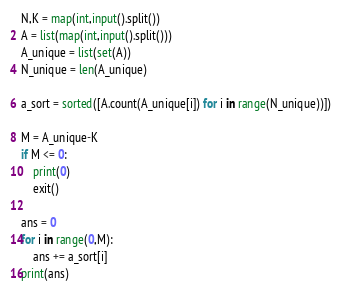<code> <loc_0><loc_0><loc_500><loc_500><_Python_>N,K = map(int,input().split())
A = list(map(int,input().split()))
A_unique = list(set(A))
N_unique = len(A_unique)

a_sort = sorted([A.count(A_unique[i]) for i in range(N_unique))])

M = A_unique-K
if M <= 0:
	print(0)
	exit()

ans = 0
for i in range(0,M):
	ans += a_sort[i]
print(ans)</code> 